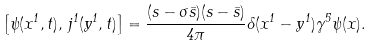<formula> <loc_0><loc_0><loc_500><loc_500>\left [ \psi ( x ^ { 1 } , t ) , \, j ^ { 1 } ( y ^ { 1 } , t ) \right ] = \frac { ( s - \sigma \bar { s } ) ( s - \bar { s } ) } { 4 \pi } \delta ( x ^ { 1 } - y ^ { 1 } ) \gamma ^ { 5 } \psi ( x ) .</formula> 